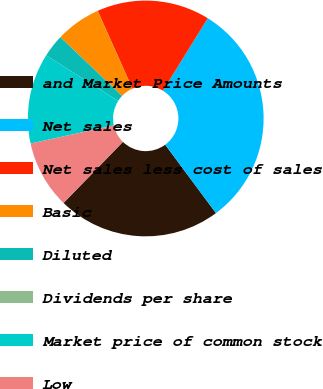Convert chart to OTSL. <chart><loc_0><loc_0><loc_500><loc_500><pie_chart><fcel>and Market Price Amounts<fcel>Net sales<fcel>Net sales less cost of sales<fcel>Basic<fcel>Diluted<fcel>Dividends per share<fcel>Market price of common stock<fcel>Low<nl><fcel>22.44%<fcel>31.02%<fcel>15.51%<fcel>6.21%<fcel>3.11%<fcel>0.0%<fcel>12.41%<fcel>9.31%<nl></chart> 